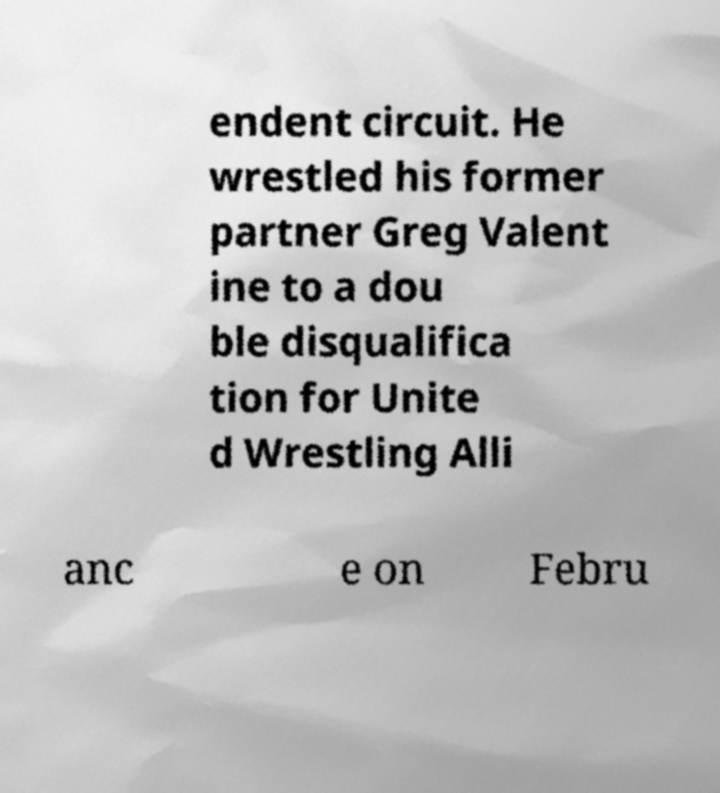Could you assist in decoding the text presented in this image and type it out clearly? endent circuit. He wrestled his former partner Greg Valent ine to a dou ble disqualifica tion for Unite d Wrestling Alli anc e on Febru 